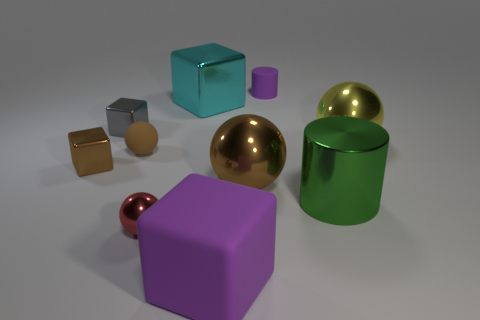Subtract 1 blocks. How many blocks are left? 3 Subtract all balls. How many objects are left? 6 Subtract all big purple matte objects. Subtract all brown matte things. How many objects are left? 8 Add 6 gray metallic blocks. How many gray metallic blocks are left? 7 Add 10 small purple matte balls. How many small purple matte balls exist? 10 Subtract 1 yellow balls. How many objects are left? 9 